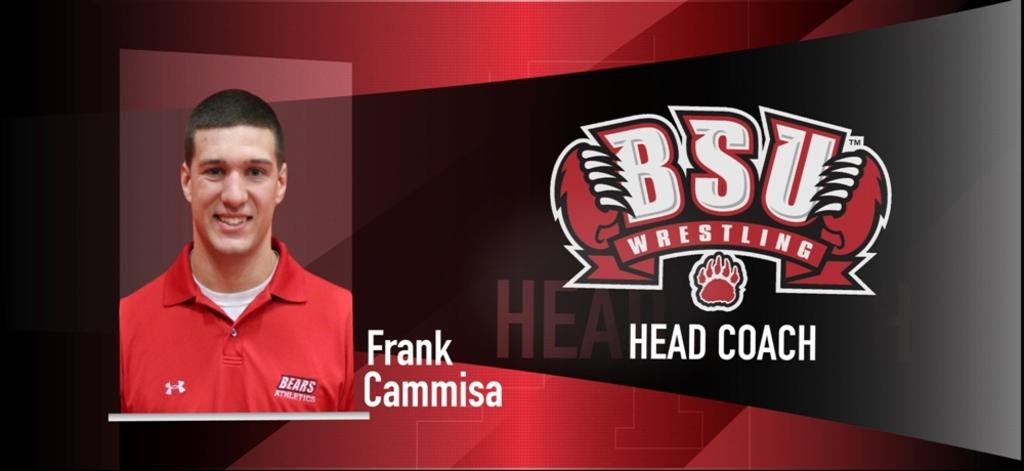<image>
Write a terse but informative summary of the picture. A picture of Frank Cammisa is displayed next to the logo for BSU wrestling. 